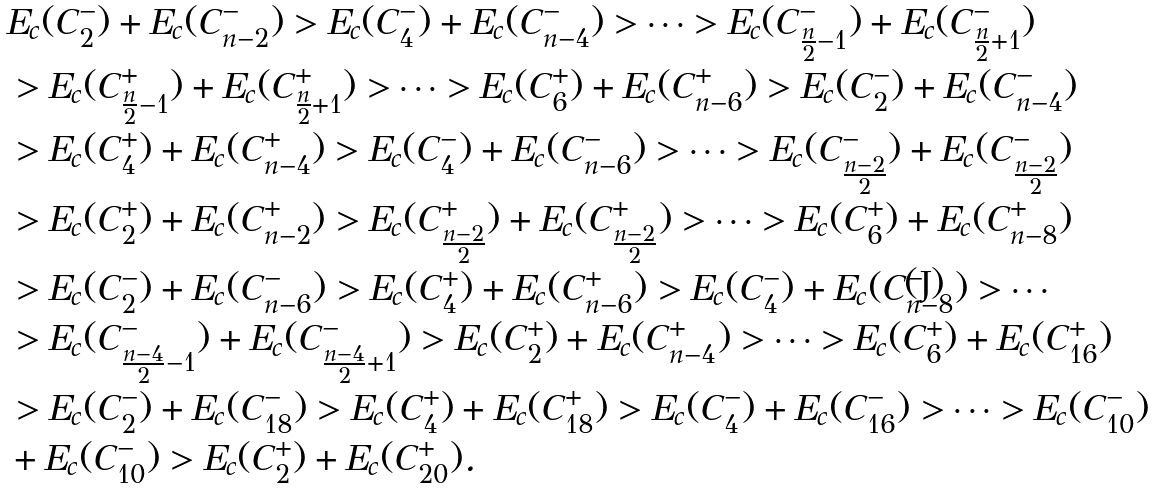Convert formula to latex. <formula><loc_0><loc_0><loc_500><loc_500>& E _ { c } ( C _ { 2 } ^ { - } ) + E _ { c } ( C _ { n - 2 } ^ { - } ) > E _ { c } ( C _ { 4 } ^ { - } ) + E _ { c } ( C _ { n - 4 } ^ { - } ) > \cdots > E _ { c } ( C _ { \frac { n } { 2 } - 1 } ^ { - } ) + E _ { c } ( C _ { \frac { n } { 2 } + 1 } ^ { - } ) \\ & > E _ { c } ( C _ { \frac { n } { 2 } - 1 } ^ { + } ) + E _ { c } ( C _ { \frac { n } { 2 } + 1 } ^ { + } ) > \cdots > E _ { c } ( C _ { 6 } ^ { + } ) + E _ { c } ( C _ { n - 6 } ^ { + } ) > E _ { c } ( C _ { 2 } ^ { - } ) + E _ { c } ( C _ { n - 4 } ^ { - } ) \\ & > E _ { c } ( C _ { 4 } ^ { + } ) + E _ { c } ( C _ { n - 4 } ^ { + } ) > E _ { c } ( C _ { 4 } ^ { - } ) + E _ { c } ( C _ { n - 6 } ^ { - } ) > \cdots > E _ { c } ( C _ { \frac { n - 2 } { 2 } } ^ { - } ) + E _ { c } ( C _ { \frac { n - 2 } { 2 } } ^ { - } ) \\ & > E _ { c } ( C _ { 2 } ^ { + } ) + E _ { c } ( C _ { n - 2 } ^ { + } ) > E _ { c } ( C _ { \frac { n - 2 } { 2 } } ^ { + } ) + E _ { c } ( C _ { \frac { n - 2 } { 2 } } ^ { + } ) > \cdots > E _ { c } ( C _ { 6 } ^ { + } ) + E _ { c } ( C _ { n - 8 } ^ { + } ) \\ & > E _ { c } ( C _ { 2 } ^ { - } ) + E _ { c } ( C _ { n - 6 } ^ { - } ) > E _ { c } ( C _ { 4 } ^ { + } ) + E _ { c } ( C _ { n - 6 } ^ { + } ) > E _ { c } ( C _ { 4 } ^ { - } ) + E _ { c } ( C _ { n - 8 } ^ { - } ) > \cdots \\ & > E _ { c } ( C _ { \frac { n - 4 } { 2 } - 1 } ^ { - } ) + E _ { c } ( C _ { \frac { n - 4 } { 2 } + 1 } ^ { - } ) > E _ { c } ( C _ { 2 } ^ { + } ) + E _ { c } ( C _ { n - 4 } ^ { + } ) > \cdots > E _ { c } ( C _ { 6 } ^ { + } ) + E _ { c } ( C _ { 1 6 } ^ { + } ) \\ & > E _ { c } ( C _ { 2 } ^ { - } ) + E _ { c } ( C _ { 1 8 } ^ { - } ) > E _ { c } ( C _ { 4 } ^ { + } ) + E _ { c } ( C _ { 1 8 } ^ { + } ) > E _ { c } ( C _ { 4 } ^ { - } ) + E _ { c } ( C _ { 1 6 } ^ { - } ) > \cdots > E _ { c } ( C _ { 1 0 } ^ { - } ) \\ & + E _ { c } ( C _ { 1 0 } ^ { - } ) > E _ { c } ( C _ { 2 } ^ { + } ) + E _ { c } ( C _ { 2 0 } ^ { + } ) .</formula> 